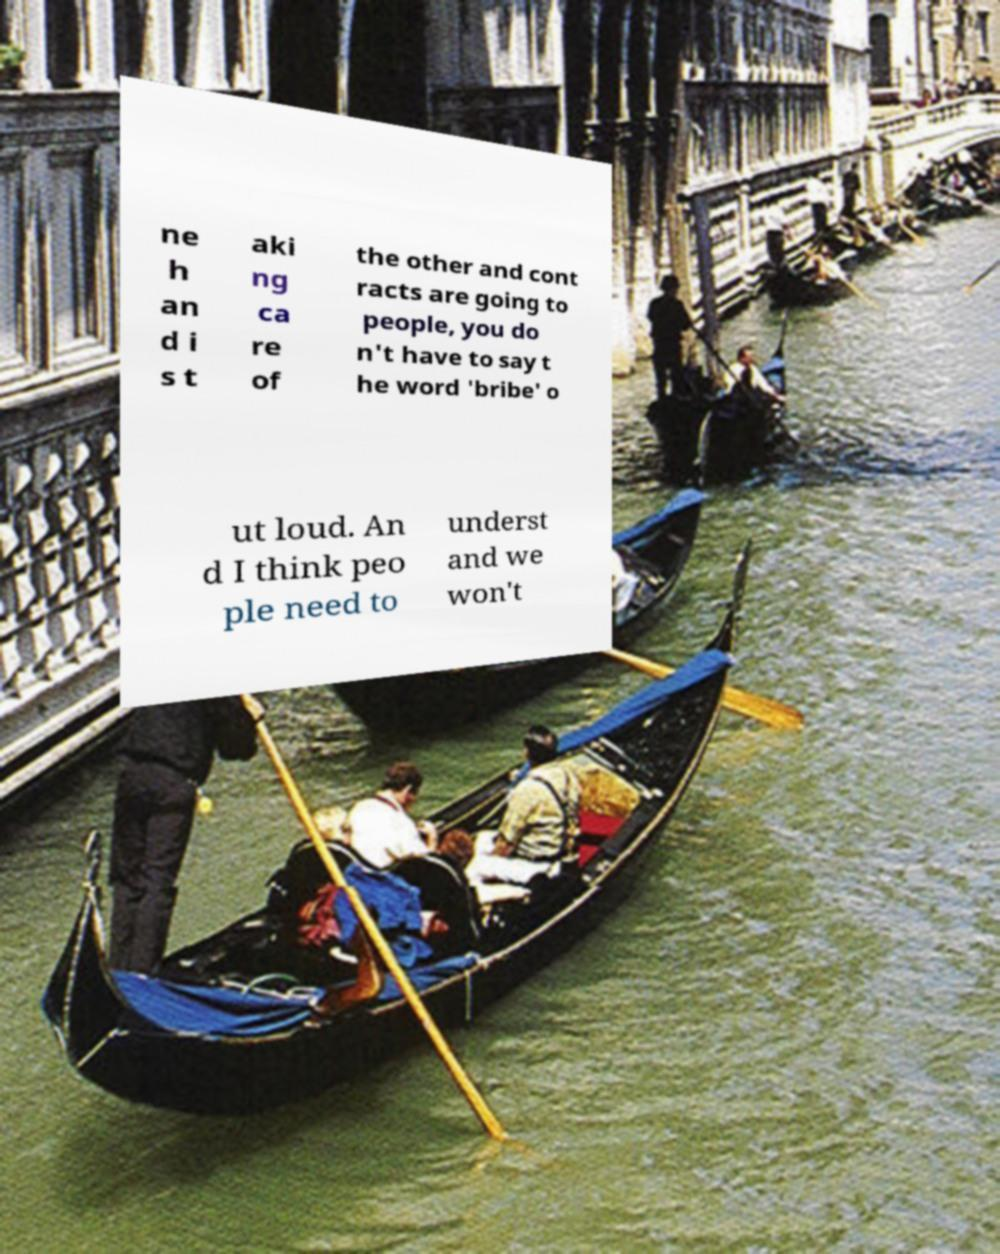What messages or text are displayed in this image? I need them in a readable, typed format. ne h an d i s t aki ng ca re of the other and cont racts are going to people, you do n't have to say t he word 'bribe' o ut loud. An d I think peo ple need to underst and we won't 